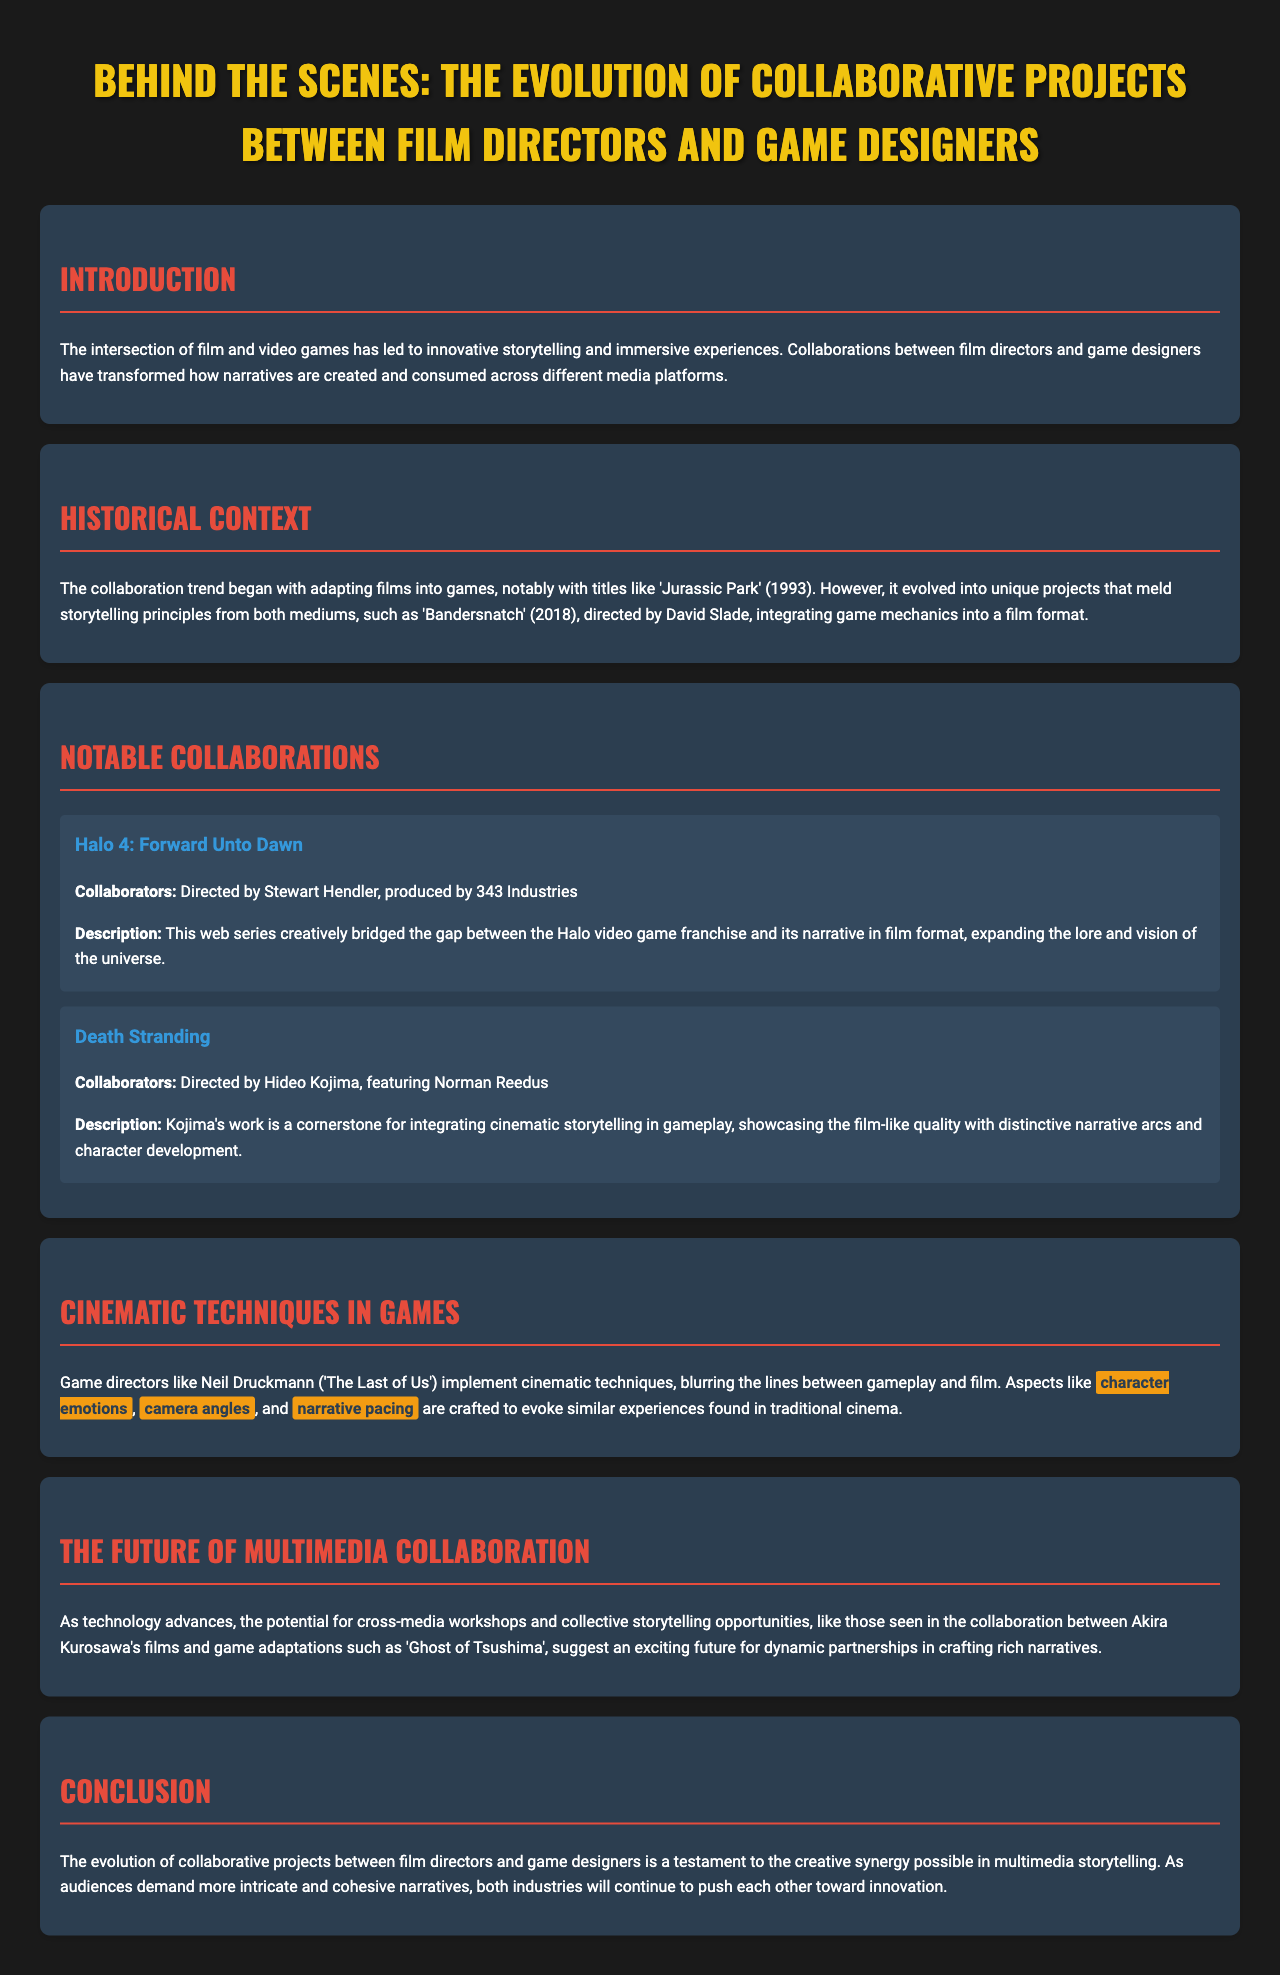what is the title of the brochure? The title is stated at the top of the document as "Behind the Scenes: The Evolution of Collaborative Projects between Film Directors and Game Designers."
Answer: Behind the Scenes: The Evolution of Collaborative Projects between Film Directors and Game Designers who directed 'Halo 4: Forward Unto Dawn'? The brochure mentions Stewart Hendler as the director of 'Halo 4: Forward Unto Dawn.'
Answer: Stewart Hendler what year was 'Bandersnatch' released? The document states 'Bandersnatch' was released in 2018.
Answer: 2018 what is the main focus of the "Cinematic Techniques in Games" section? This section discusses how game directors implement cinematic techniques in gameplay, highlighting emotional aspects, camera angles, and narrative pacing.
Answer: Cinematic techniques name a game that showcases the integration of cinematic storytelling. The brochure specifically mentions 'Death Stranding' as a work showcasing cinematic storytelling.
Answer: Death Stranding what is highlighted as a potential future collaboration example? The document cites Akira Kurosawa's films and the game adaptation 'Ghost of Tsushima' as an example of future collaboration.
Answer: Ghost of Tsushima how has the collaboration trend evolved? It has evolved from adapting films into games to creating unique projects that combine storytelling principles from both mediums.
Answer: Unique projects what is a key theme in the brochure's conclusion? The conclusion emphasizes the creative synergy possible in multimedia storytelling as a testament to collaboration between the two industries.
Answer: Creative synergy 